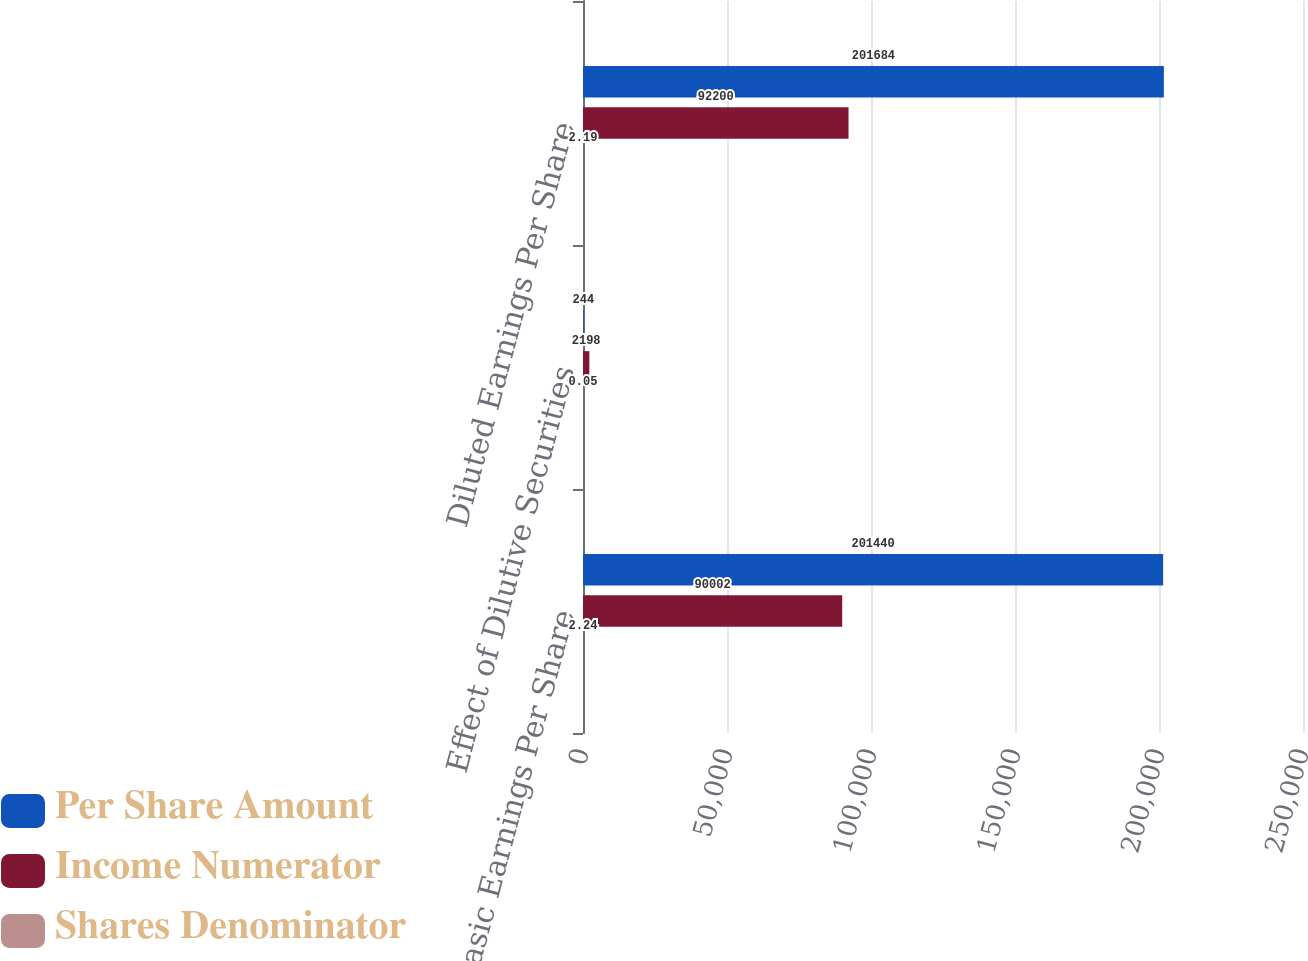Convert chart. <chart><loc_0><loc_0><loc_500><loc_500><stacked_bar_chart><ecel><fcel>Basic Earnings Per Share<fcel>Effect of Dilutive Securities<fcel>Diluted Earnings Per Share<nl><fcel>Per Share Amount<fcel>201440<fcel>244<fcel>201684<nl><fcel>Income Numerator<fcel>90002<fcel>2198<fcel>92200<nl><fcel>Shares Denominator<fcel>2.24<fcel>0.05<fcel>2.19<nl></chart> 